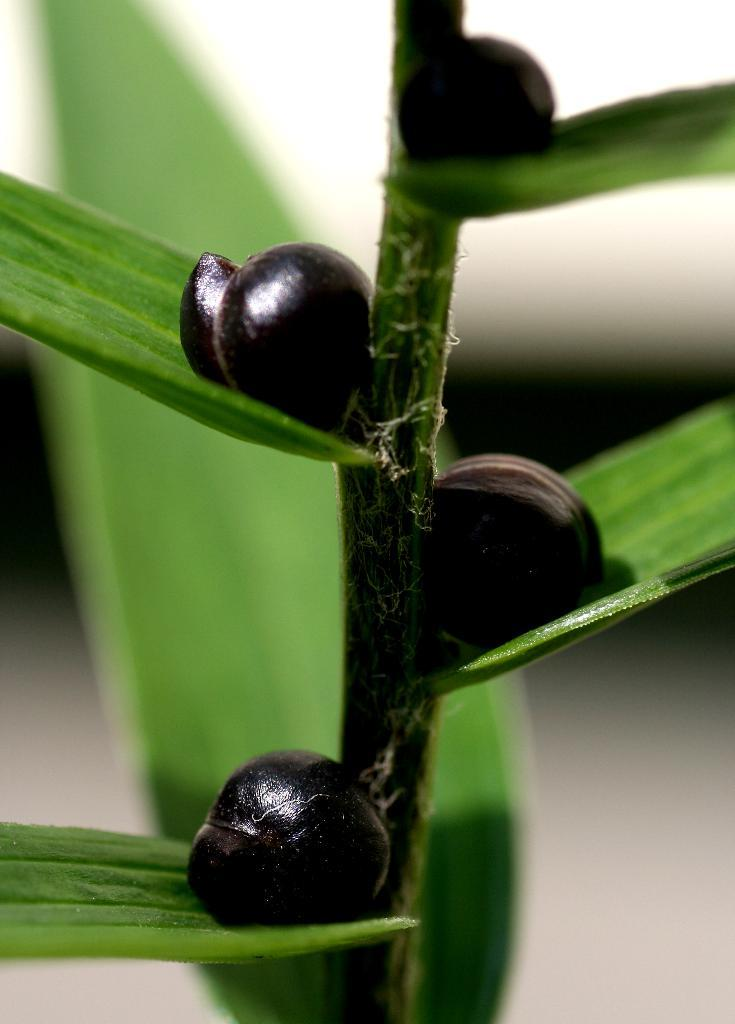What type of living organism can be seen in the image? There is a plant in the image. What else can be seen in the image besides the plant? There are fruits in the image. What type of competition is taking place in the image? There is no competition present in the image. What effect does the plant have on the fruits in the image? The image does not depict any effect the plant might have on the fruits; it simply shows the plant and the fruits together. 